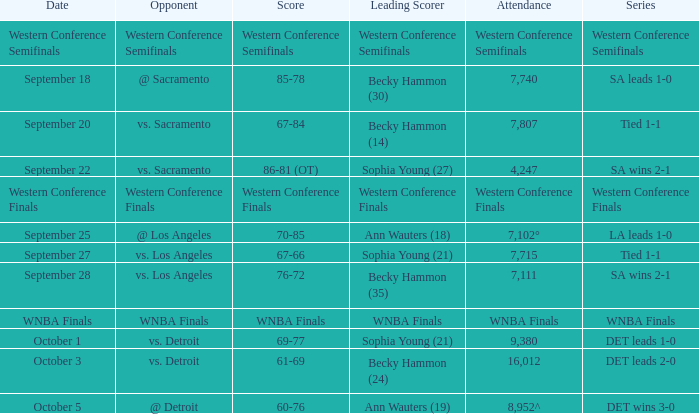What is the crowd size at the western conference finals series? Western Conference Finals. 